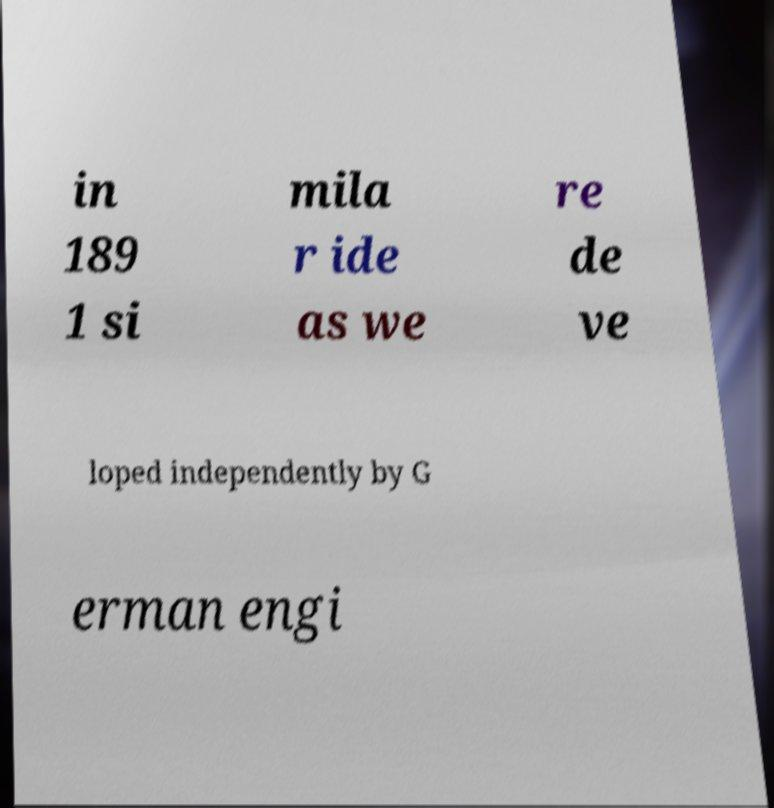Can you accurately transcribe the text from the provided image for me? in 189 1 si mila r ide as we re de ve loped independently by G erman engi 